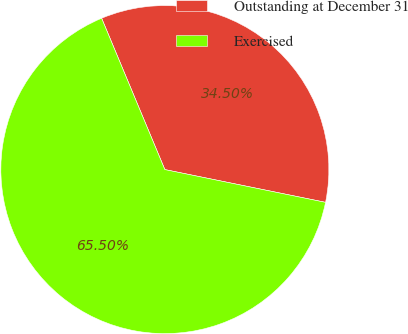Convert chart to OTSL. <chart><loc_0><loc_0><loc_500><loc_500><pie_chart><fcel>Outstanding at December 31<fcel>Exercised<nl><fcel>34.5%<fcel>65.5%<nl></chart> 